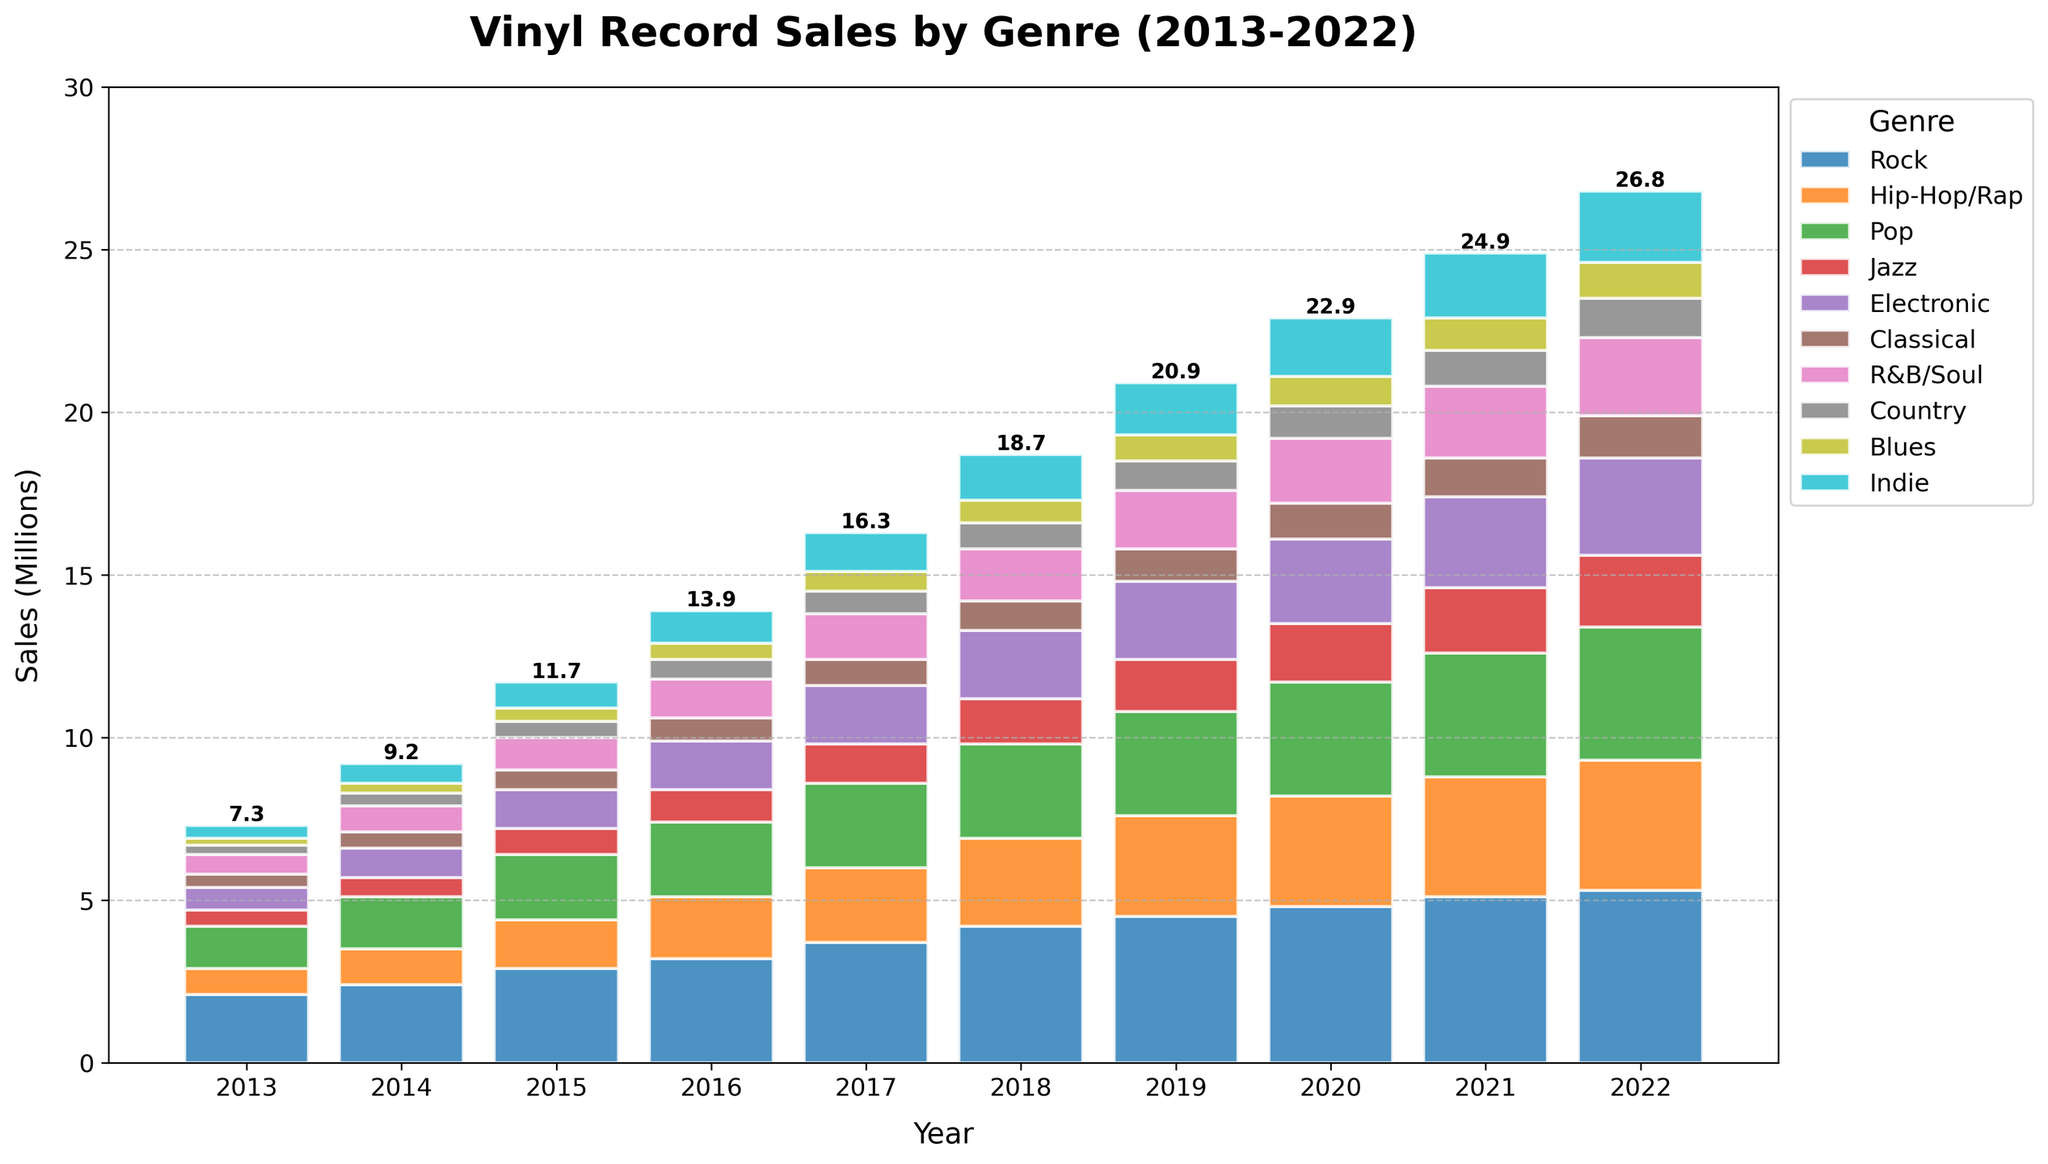What genre shows the highest sales in 2022? By looking at the topmost segment of the stacked bar for 2022, we can see that the Rock genre has the highest sales
Answer: Rock How much did Vinyl sales for the Rock genre increase from 2013 to 2022? To find the increase, subtract the sales in 2013 from the sales in 2022 for the Rock genre: 5.3 - 2.1 = 3.2 million
Answer: 3.2 million Which genre recorded the least sales growth between 2013 and 2022? Comparing the sales in 2013 and 2022 for each genre, Classical shows the smallest increase: 1.3 - 0.4 = 0.9 million
Answer: Classical Between 2013 and 2022, did any genre surpass the sales of Rock in any given year? By visually comparing the height of the Rock segment with other genre segments across all years, no genre surpassed Rock
Answer: No How do the total sales in 2013 compare to the total sales in 2022? Add up the total sales for each year from all genres, and compare: 2013 (7.3 million) vs 2022 (25.8 million). Calculate: 25.8 - 7.3 = 18.5 million
Answer: 25.8 million (2022) Which genres have consistently grown every year from 2013 to 2022? Observe the trend lines for each genre to find that Rock, Hip-Hop/Rap, Pop, Jazz, Electronic, R&B/Soul consistently rise annually
Answer: Rock, Hip-Hop/Rap, Pop, Jazz, Electronic, R&B/Soul What is the combined sales figure for Indie and Electronic genres in 2022? Add the sales for both genres in 2022: Indie (2.2 million) + Electronic (3.0 million) = 5.2 million
Answer: 5.2 million Which year showed the greatest increase in total sales compared to the previous year? Subtract total sales for each year from the sales of the previous year and identify the largest difference; 2017-2018 has the greatest increase: (16.9 - 13.3 = 3.6 million)
Answer: 2017-2018 How has the sales trend for Country genre changed over the decade? Examine the bar heights for Country from 2013 to 2022 and note that it has grown steadily from 0.3 million to 1.2 million
Answer: Steady growth What are the total vinyl sales across all genres in 2015? Sum the sales for all genres in 2015: Rock (2.9) + Hip-Hop/Rap (1.5) + Pop (2.0) + Jazz (0.8) + Electronic (1.2) + Classical (0.6) + R&B/Soul (1.0) + Country (0.5) + Blues (0.4) + Indie (0.8) = 11.7 million
Answer: 11.7 million 